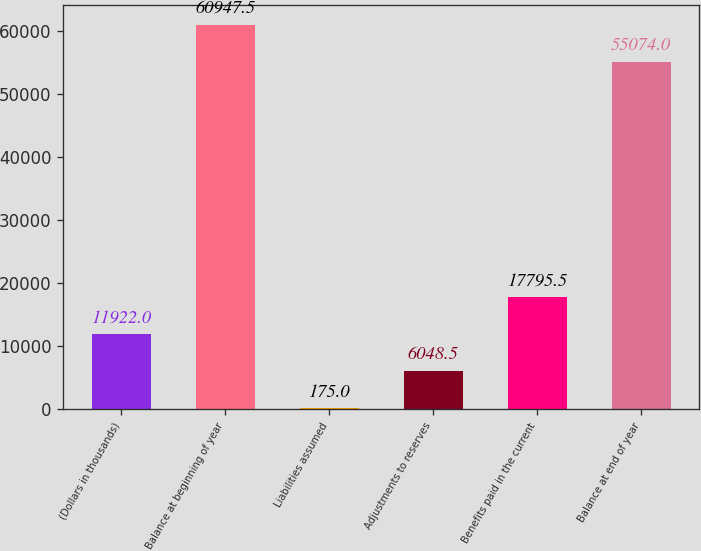<chart> <loc_0><loc_0><loc_500><loc_500><bar_chart><fcel>(Dollars in thousands)<fcel>Balance at beginning of year<fcel>Liabilities assumed<fcel>Adjustments to reserves<fcel>Benefits paid in the current<fcel>Balance at end of year<nl><fcel>11922<fcel>60947.5<fcel>175<fcel>6048.5<fcel>17795.5<fcel>55074<nl></chart> 